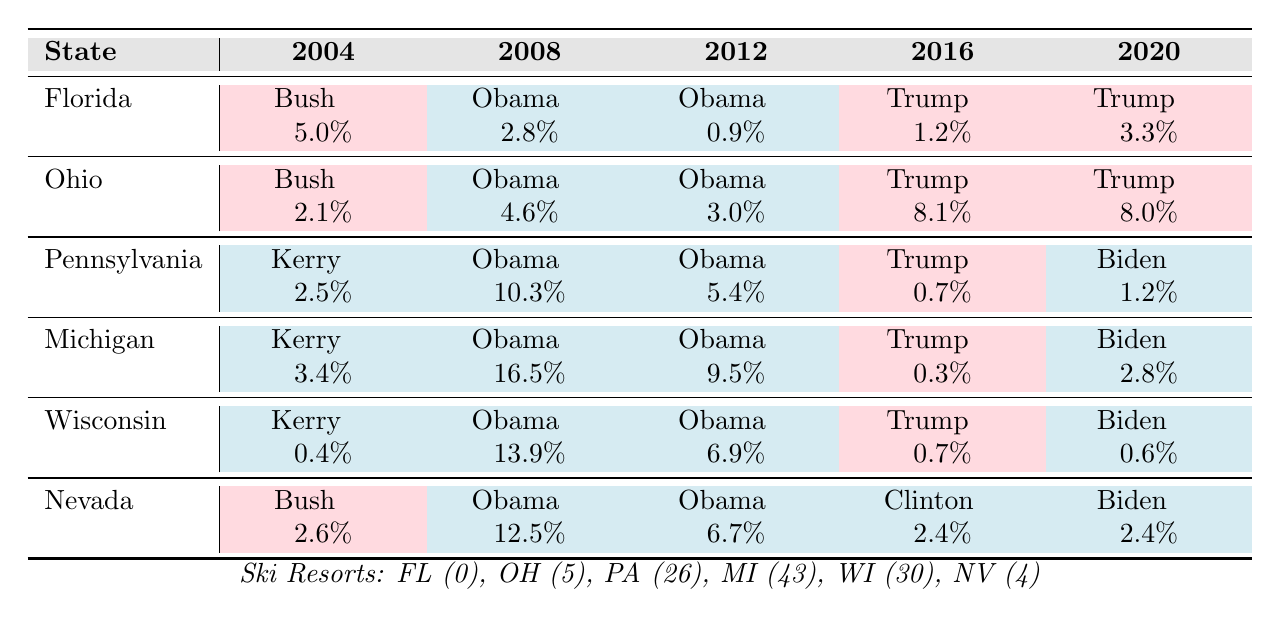What was the winner in Florida for the 2012 election? In the table, the 2012 winner listed for Florida is Obama.
Answer: Obama Which state had the highest voter margin for Obama in 2008? Looking at the 2008 column, Michigan shows the highest margin of 16.5% for Obama, compared to other states.
Answer: Michigan How many ski resorts are in Pennsylvania? The table states that there are 26 ski resorts in Pennsylvania.
Answer: 26 Which state voted for Bush in both the 2004 and 2016 elections? In the table, Florida is shown as the winner for Bush in 2004 and Trump (a Republican) in 2016, indicating a consistent Republican preference.
Answer: Florida What is the average margin for Trump across all elections? Calculating the margins for Trump: 1.2% (2016) + 3.3% (2020) = 4.5%. Divided by 2 years gives an average of 4.5% / 2 = 2.25%.
Answer: 2.25% Did Pennsylvania vote for Obama in 2012? Yes, the table indicates that in 2012, Obama was the winner in Pennsylvania.
Answer: Yes Which state switched to Biden in the 2020 election from Trump in 2016? The table indicates that both Michigan and Pennsylvania switched to Biden from Trump, as Trump won in 2016 and Biden in 2020.
Answer: Michigan and Pennsylvania Calculate the total number of ski resorts in all listed swing states. Adding the ski resorts: 0 (FL) + 5 (OH) + 26 (PA) + 43 (MI) + 30 (WI) + 4 (NV) = 108 total ski resorts.
Answer: 108 What percentage margin did Obama win by in the 2008 election in Nevada? The 2008 margin for Nevada shows Obama won by 12.5%.
Answer: 12.5% Which candidate had the highest margin of victory in Michigan? In 2008, Obama had the highest margin in Michigan at 16.5%.
Answer: Obama Explain if Ohio transitioned from a Democrat to a Republican vote between the 2008 and 2016 elections. In 2008, Ohio voted for Obama with a 4.6% margin and switched to Trump in 2016 with an 8.1% margin, indicating a transition from Democrat to Republican.
Answer: Yes 